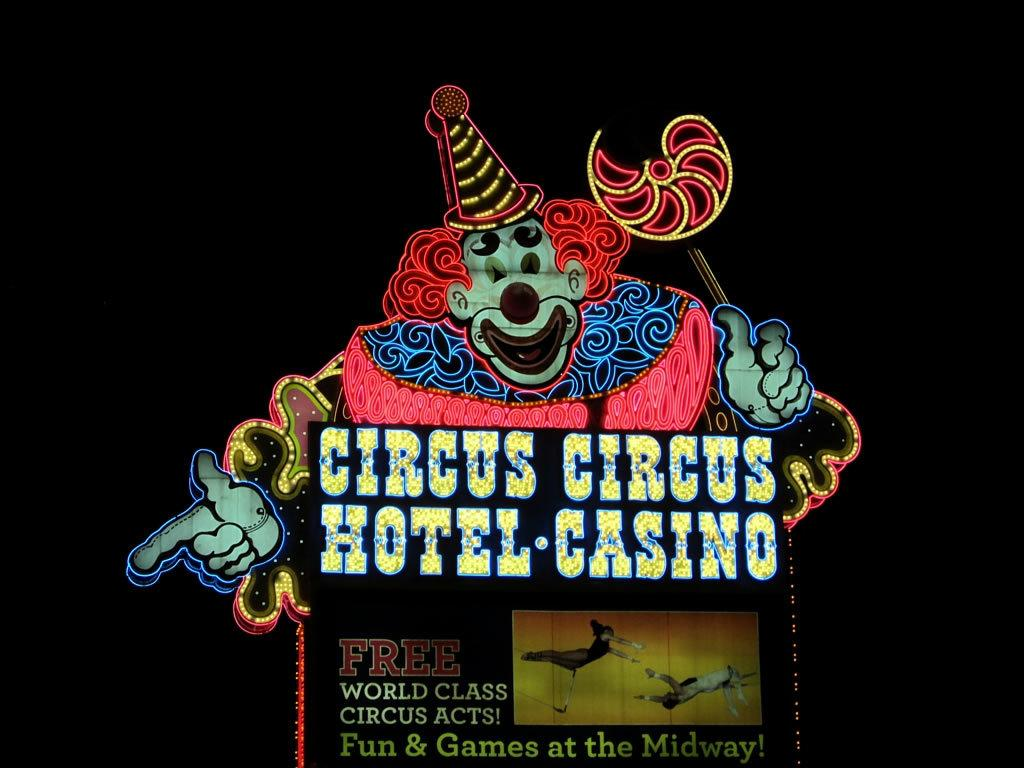<image>
Present a compact description of the photo's key features. A large sign for the casino Circus Circus is lit up. 